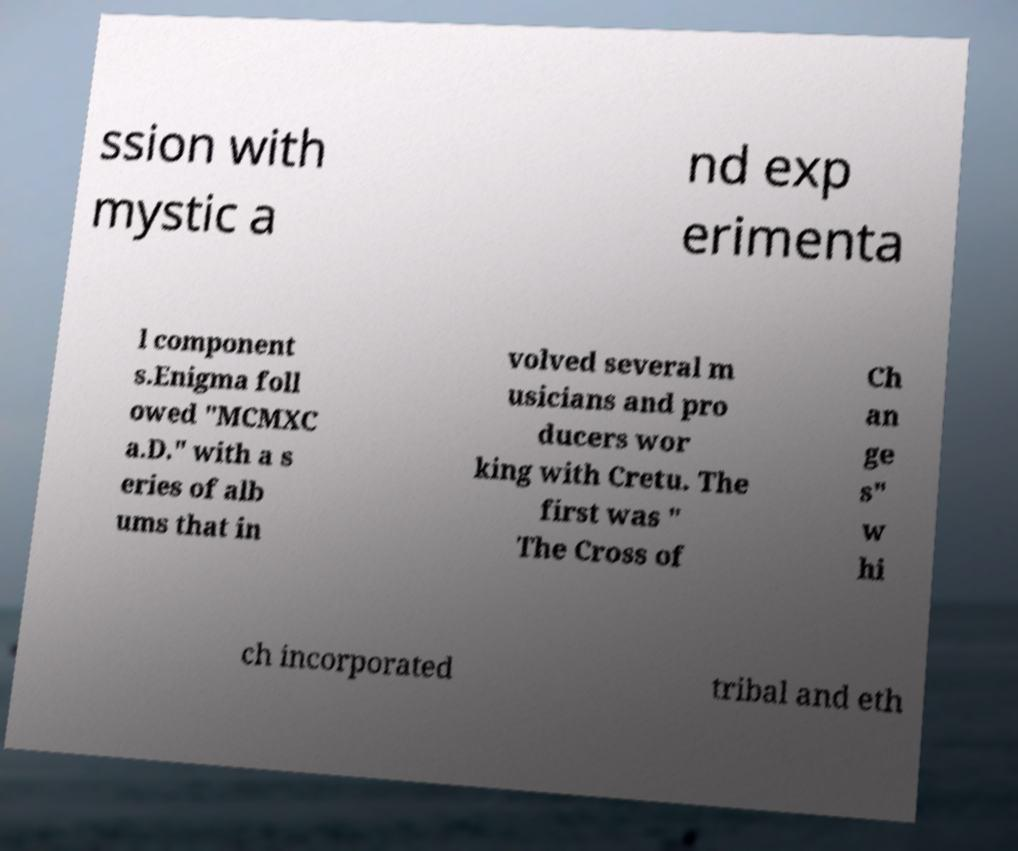I need the written content from this picture converted into text. Can you do that? ssion with mystic a nd exp erimenta l component s.Enigma foll owed "MCMXC a.D." with a s eries of alb ums that in volved several m usicians and pro ducers wor king with Cretu. The first was " The Cross of Ch an ge s" w hi ch incorporated tribal and eth 